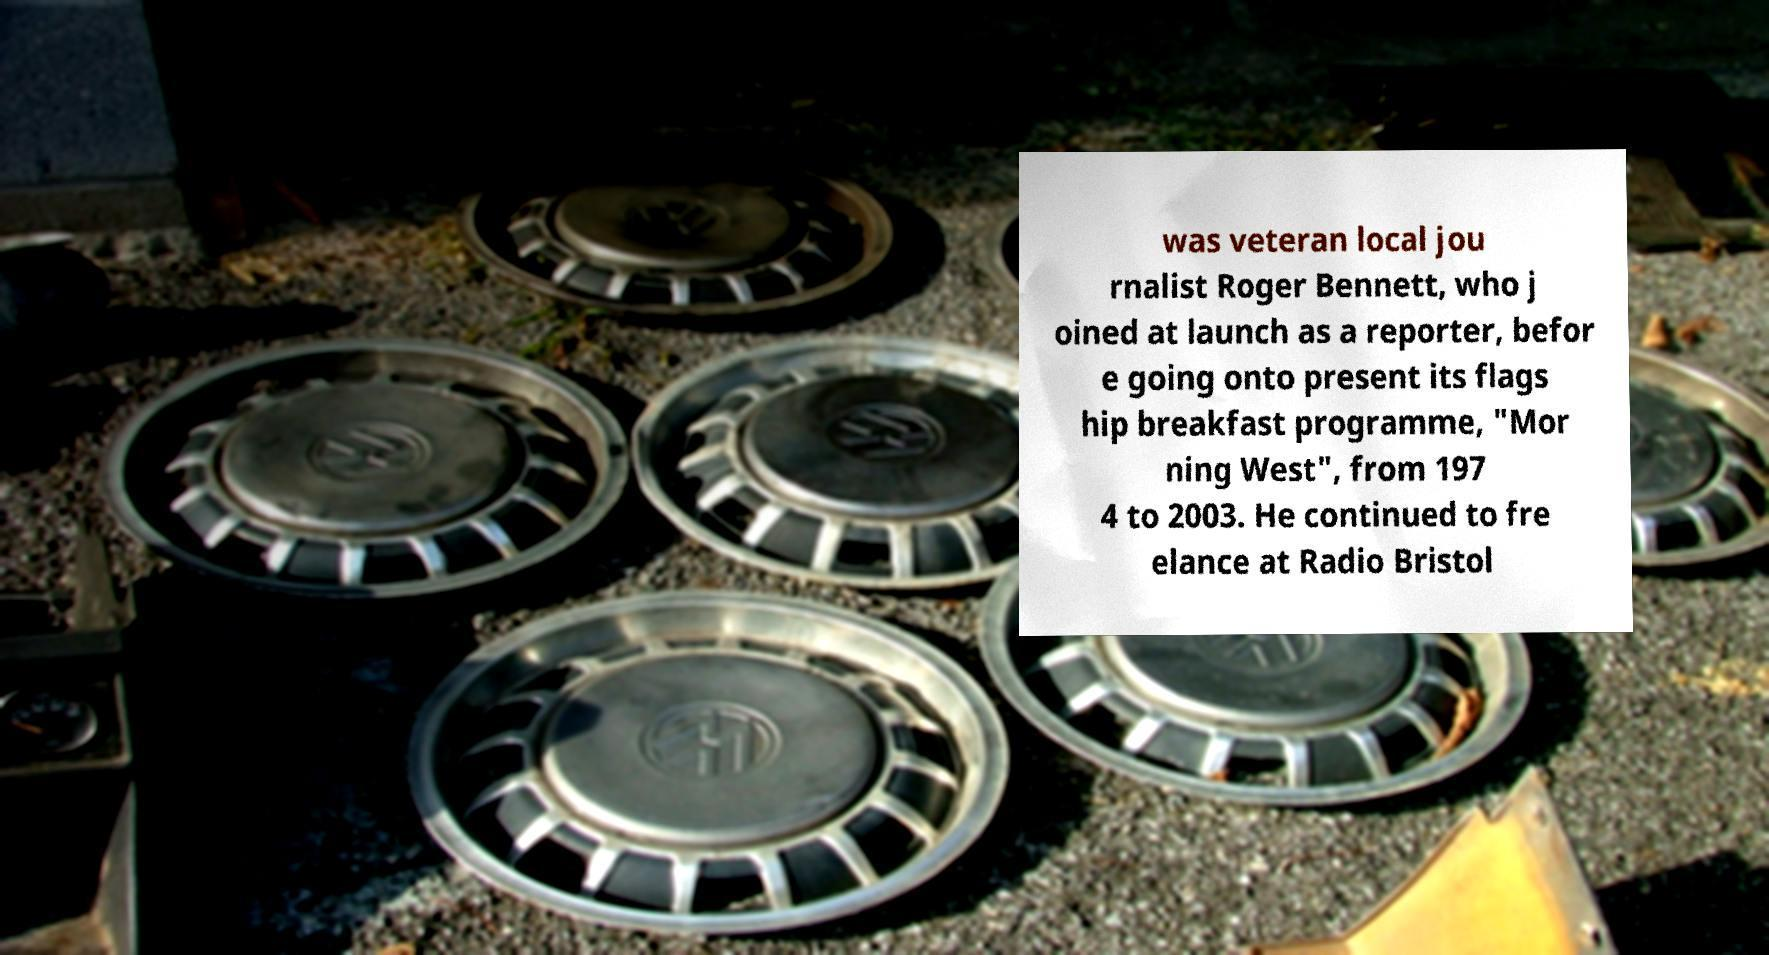I need the written content from this picture converted into text. Can you do that? was veteran local jou rnalist Roger Bennett, who j oined at launch as a reporter, befor e going onto present its flags hip breakfast programme, "Mor ning West", from 197 4 to 2003. He continued to fre elance at Radio Bristol 